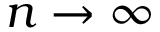Convert formula to latex. <formula><loc_0><loc_0><loc_500><loc_500>n \to \infty</formula> 